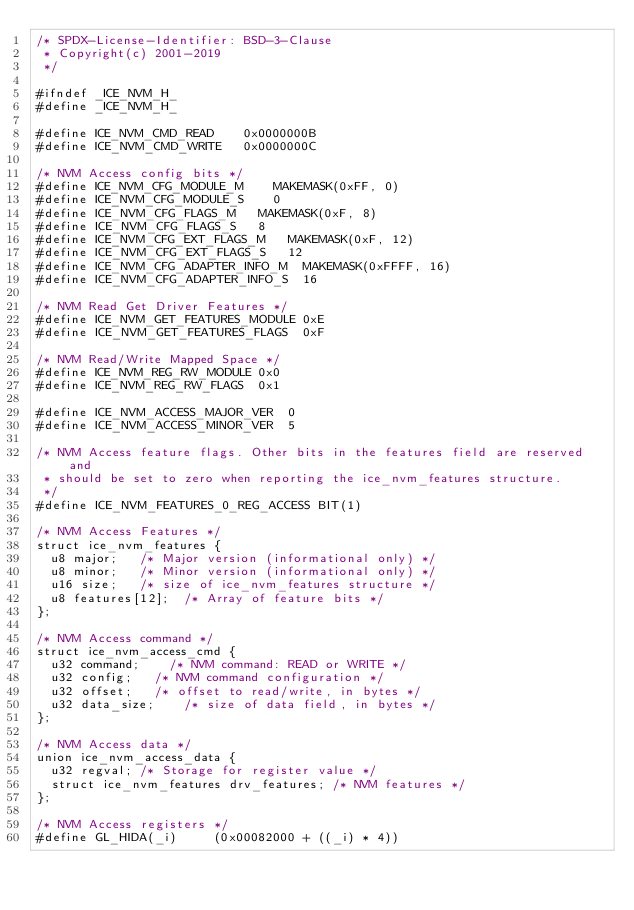<code> <loc_0><loc_0><loc_500><loc_500><_C_>/* SPDX-License-Identifier: BSD-3-Clause
 * Copyright(c) 2001-2019
 */

#ifndef _ICE_NVM_H_
#define _ICE_NVM_H_

#define ICE_NVM_CMD_READ		0x0000000B
#define ICE_NVM_CMD_WRITE		0x0000000C

/* NVM Access config bits */
#define ICE_NVM_CFG_MODULE_M		MAKEMASK(0xFF, 0)
#define ICE_NVM_CFG_MODULE_S		0
#define ICE_NVM_CFG_FLAGS_M		MAKEMASK(0xF, 8)
#define ICE_NVM_CFG_FLAGS_S		8
#define ICE_NVM_CFG_EXT_FLAGS_M		MAKEMASK(0xF, 12)
#define ICE_NVM_CFG_EXT_FLAGS_S		12
#define ICE_NVM_CFG_ADAPTER_INFO_M	MAKEMASK(0xFFFF, 16)
#define ICE_NVM_CFG_ADAPTER_INFO_S	16

/* NVM Read Get Driver Features */
#define ICE_NVM_GET_FEATURES_MODULE	0xE
#define ICE_NVM_GET_FEATURES_FLAGS	0xF

/* NVM Read/Write Mapped Space */
#define ICE_NVM_REG_RW_MODULE	0x0
#define ICE_NVM_REG_RW_FLAGS	0x1

#define ICE_NVM_ACCESS_MAJOR_VER	0
#define ICE_NVM_ACCESS_MINOR_VER	5

/* NVM Access feature flags. Other bits in the features field are reserved and
 * should be set to zero when reporting the ice_nvm_features structure.
 */
#define ICE_NVM_FEATURES_0_REG_ACCESS	BIT(1)

/* NVM Access Features */
struct ice_nvm_features {
	u8 major;		/* Major version (informational only) */
	u8 minor;		/* Minor version (informational only) */
	u16 size;		/* size of ice_nvm_features structure */
	u8 features[12];	/* Array of feature bits */
};

/* NVM Access command */
struct ice_nvm_access_cmd {
	u32 command;		/* NVM command: READ or WRITE */
	u32 config;		/* NVM command configuration */
	u32 offset;		/* offset to read/write, in bytes */
	u32 data_size;		/* size of data field, in bytes */
};

/* NVM Access data */
union ice_nvm_access_data {
	u32 regval;	/* Storage for register value */
	struct ice_nvm_features drv_features; /* NVM features */
};

/* NVM Access registers */
#define GL_HIDA(_i)			(0x00082000 + ((_i) * 4))</code> 